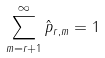<formula> <loc_0><loc_0><loc_500><loc_500>\sum _ { m = r + 1 } ^ { \infty } \hat { p } _ { r , m } = 1</formula> 